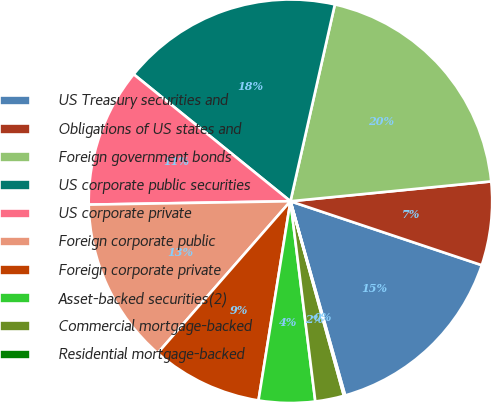Convert chart. <chart><loc_0><loc_0><loc_500><loc_500><pie_chart><fcel>US Treasury securities and<fcel>Obligations of US states and<fcel>Foreign government bonds<fcel>US corporate public securities<fcel>US corporate private<fcel>Foreign corporate public<fcel>Foreign corporate private<fcel>Asset-backed securities(2)<fcel>Commercial mortgage-backed<fcel>Residential mortgage-backed<nl><fcel>15.5%<fcel>6.7%<fcel>19.9%<fcel>17.7%<fcel>11.1%<fcel>13.3%<fcel>8.9%<fcel>4.5%<fcel>2.3%<fcel>0.1%<nl></chart> 